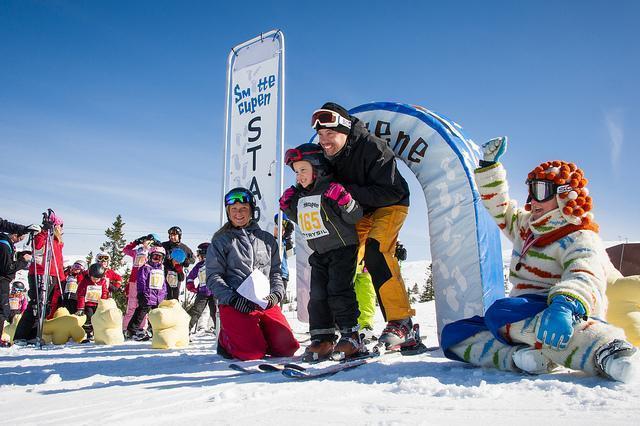How many people are there?
Give a very brief answer. 6. How many baby elephants are there?
Give a very brief answer. 0. 